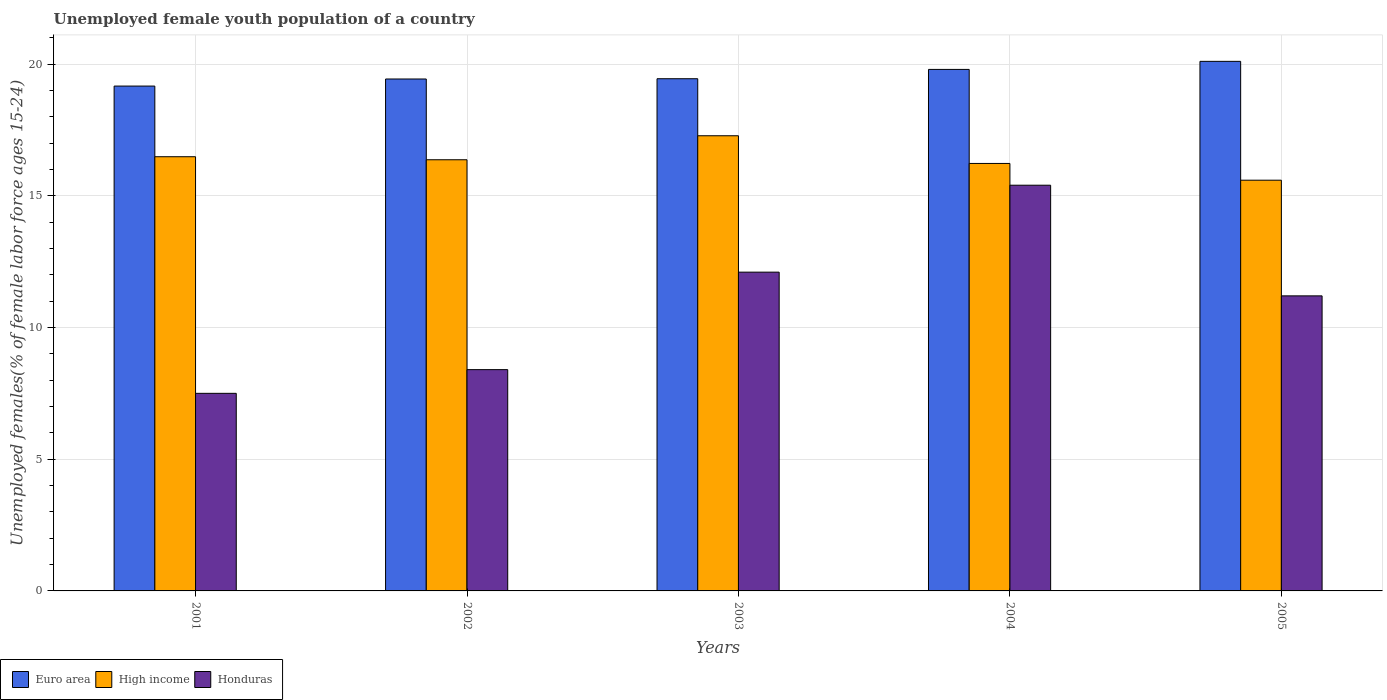Are the number of bars per tick equal to the number of legend labels?
Your answer should be very brief. Yes. How many bars are there on the 5th tick from the left?
Provide a succinct answer. 3. What is the label of the 5th group of bars from the left?
Keep it short and to the point. 2005. What is the percentage of unemployed female youth population in High income in 2002?
Offer a very short reply. 16.37. Across all years, what is the maximum percentage of unemployed female youth population in High income?
Keep it short and to the point. 17.28. Across all years, what is the minimum percentage of unemployed female youth population in Euro area?
Your response must be concise. 19.16. What is the total percentage of unemployed female youth population in High income in the graph?
Offer a terse response. 81.94. What is the difference between the percentage of unemployed female youth population in High income in 2003 and that in 2005?
Your answer should be compact. 1.69. What is the difference between the percentage of unemployed female youth population in High income in 2005 and the percentage of unemployed female youth population in Honduras in 2002?
Give a very brief answer. 7.19. What is the average percentage of unemployed female youth population in Euro area per year?
Your answer should be compact. 19.59. In the year 2001, what is the difference between the percentage of unemployed female youth population in Euro area and percentage of unemployed female youth population in High income?
Ensure brevity in your answer.  2.68. In how many years, is the percentage of unemployed female youth population in High income greater than 11 %?
Provide a short and direct response. 5. What is the ratio of the percentage of unemployed female youth population in High income in 2001 to that in 2002?
Your answer should be very brief. 1.01. Is the percentage of unemployed female youth population in Euro area in 2002 less than that in 2005?
Offer a terse response. Yes. Is the difference between the percentage of unemployed female youth population in Euro area in 2001 and 2004 greater than the difference between the percentage of unemployed female youth population in High income in 2001 and 2004?
Your answer should be compact. No. What is the difference between the highest and the second highest percentage of unemployed female youth population in Honduras?
Provide a succinct answer. 3.3. What is the difference between the highest and the lowest percentage of unemployed female youth population in Euro area?
Give a very brief answer. 0.94. How many years are there in the graph?
Your answer should be very brief. 5. Does the graph contain any zero values?
Ensure brevity in your answer.  No. Does the graph contain grids?
Your answer should be compact. Yes. How many legend labels are there?
Your answer should be compact. 3. What is the title of the graph?
Give a very brief answer. Unemployed female youth population of a country. Does "Kazakhstan" appear as one of the legend labels in the graph?
Offer a very short reply. No. What is the label or title of the X-axis?
Keep it short and to the point. Years. What is the label or title of the Y-axis?
Keep it short and to the point. Unemployed females(% of female labor force ages 15-24). What is the Unemployed females(% of female labor force ages 15-24) of Euro area in 2001?
Provide a short and direct response. 19.16. What is the Unemployed females(% of female labor force ages 15-24) of High income in 2001?
Ensure brevity in your answer.  16.48. What is the Unemployed females(% of female labor force ages 15-24) in Euro area in 2002?
Your answer should be compact. 19.43. What is the Unemployed females(% of female labor force ages 15-24) of High income in 2002?
Your answer should be very brief. 16.37. What is the Unemployed females(% of female labor force ages 15-24) in Honduras in 2002?
Keep it short and to the point. 8.4. What is the Unemployed females(% of female labor force ages 15-24) of Euro area in 2003?
Your answer should be compact. 19.44. What is the Unemployed females(% of female labor force ages 15-24) of High income in 2003?
Your response must be concise. 17.28. What is the Unemployed females(% of female labor force ages 15-24) of Honduras in 2003?
Give a very brief answer. 12.1. What is the Unemployed females(% of female labor force ages 15-24) of Euro area in 2004?
Your answer should be very brief. 19.8. What is the Unemployed females(% of female labor force ages 15-24) of High income in 2004?
Offer a very short reply. 16.23. What is the Unemployed females(% of female labor force ages 15-24) of Honduras in 2004?
Your response must be concise. 15.4. What is the Unemployed females(% of female labor force ages 15-24) in Euro area in 2005?
Make the answer very short. 20.1. What is the Unemployed females(% of female labor force ages 15-24) of High income in 2005?
Provide a succinct answer. 15.59. What is the Unemployed females(% of female labor force ages 15-24) of Honduras in 2005?
Offer a terse response. 11.2. Across all years, what is the maximum Unemployed females(% of female labor force ages 15-24) of Euro area?
Offer a very short reply. 20.1. Across all years, what is the maximum Unemployed females(% of female labor force ages 15-24) of High income?
Make the answer very short. 17.28. Across all years, what is the maximum Unemployed females(% of female labor force ages 15-24) of Honduras?
Ensure brevity in your answer.  15.4. Across all years, what is the minimum Unemployed females(% of female labor force ages 15-24) of Euro area?
Make the answer very short. 19.16. Across all years, what is the minimum Unemployed females(% of female labor force ages 15-24) in High income?
Keep it short and to the point. 15.59. Across all years, what is the minimum Unemployed females(% of female labor force ages 15-24) in Honduras?
Keep it short and to the point. 7.5. What is the total Unemployed females(% of female labor force ages 15-24) of Euro area in the graph?
Offer a terse response. 97.94. What is the total Unemployed females(% of female labor force ages 15-24) in High income in the graph?
Give a very brief answer. 81.94. What is the total Unemployed females(% of female labor force ages 15-24) of Honduras in the graph?
Ensure brevity in your answer.  54.6. What is the difference between the Unemployed females(% of female labor force ages 15-24) in Euro area in 2001 and that in 2002?
Your answer should be compact. -0.27. What is the difference between the Unemployed females(% of female labor force ages 15-24) of High income in 2001 and that in 2002?
Your response must be concise. 0.11. What is the difference between the Unemployed females(% of female labor force ages 15-24) in Euro area in 2001 and that in 2003?
Ensure brevity in your answer.  -0.28. What is the difference between the Unemployed females(% of female labor force ages 15-24) of High income in 2001 and that in 2003?
Give a very brief answer. -0.8. What is the difference between the Unemployed females(% of female labor force ages 15-24) in Euro area in 2001 and that in 2004?
Your answer should be very brief. -0.63. What is the difference between the Unemployed females(% of female labor force ages 15-24) of High income in 2001 and that in 2004?
Your response must be concise. 0.25. What is the difference between the Unemployed females(% of female labor force ages 15-24) of Honduras in 2001 and that in 2004?
Your answer should be very brief. -7.9. What is the difference between the Unemployed females(% of female labor force ages 15-24) of Euro area in 2001 and that in 2005?
Provide a succinct answer. -0.94. What is the difference between the Unemployed females(% of female labor force ages 15-24) in High income in 2001 and that in 2005?
Give a very brief answer. 0.89. What is the difference between the Unemployed females(% of female labor force ages 15-24) of Euro area in 2002 and that in 2003?
Give a very brief answer. -0.01. What is the difference between the Unemployed females(% of female labor force ages 15-24) of High income in 2002 and that in 2003?
Provide a succinct answer. -0.91. What is the difference between the Unemployed females(% of female labor force ages 15-24) in Euro area in 2002 and that in 2004?
Provide a succinct answer. -0.36. What is the difference between the Unemployed females(% of female labor force ages 15-24) of High income in 2002 and that in 2004?
Your answer should be compact. 0.14. What is the difference between the Unemployed females(% of female labor force ages 15-24) in Euro area in 2002 and that in 2005?
Provide a short and direct response. -0.67. What is the difference between the Unemployed females(% of female labor force ages 15-24) of High income in 2002 and that in 2005?
Ensure brevity in your answer.  0.78. What is the difference between the Unemployed females(% of female labor force ages 15-24) of Euro area in 2003 and that in 2004?
Keep it short and to the point. -0.35. What is the difference between the Unemployed females(% of female labor force ages 15-24) in High income in 2003 and that in 2004?
Keep it short and to the point. 1.05. What is the difference between the Unemployed females(% of female labor force ages 15-24) of Honduras in 2003 and that in 2004?
Keep it short and to the point. -3.3. What is the difference between the Unemployed females(% of female labor force ages 15-24) of Euro area in 2003 and that in 2005?
Your response must be concise. -0.66. What is the difference between the Unemployed females(% of female labor force ages 15-24) of High income in 2003 and that in 2005?
Your answer should be very brief. 1.69. What is the difference between the Unemployed females(% of female labor force ages 15-24) in Euro area in 2004 and that in 2005?
Your answer should be compact. -0.31. What is the difference between the Unemployed females(% of female labor force ages 15-24) in High income in 2004 and that in 2005?
Keep it short and to the point. 0.64. What is the difference between the Unemployed females(% of female labor force ages 15-24) in Honduras in 2004 and that in 2005?
Keep it short and to the point. 4.2. What is the difference between the Unemployed females(% of female labor force ages 15-24) in Euro area in 2001 and the Unemployed females(% of female labor force ages 15-24) in High income in 2002?
Your answer should be very brief. 2.8. What is the difference between the Unemployed females(% of female labor force ages 15-24) of Euro area in 2001 and the Unemployed females(% of female labor force ages 15-24) of Honduras in 2002?
Give a very brief answer. 10.76. What is the difference between the Unemployed females(% of female labor force ages 15-24) in High income in 2001 and the Unemployed females(% of female labor force ages 15-24) in Honduras in 2002?
Ensure brevity in your answer.  8.08. What is the difference between the Unemployed females(% of female labor force ages 15-24) of Euro area in 2001 and the Unemployed females(% of female labor force ages 15-24) of High income in 2003?
Your answer should be very brief. 1.89. What is the difference between the Unemployed females(% of female labor force ages 15-24) of Euro area in 2001 and the Unemployed females(% of female labor force ages 15-24) of Honduras in 2003?
Keep it short and to the point. 7.06. What is the difference between the Unemployed females(% of female labor force ages 15-24) in High income in 2001 and the Unemployed females(% of female labor force ages 15-24) in Honduras in 2003?
Make the answer very short. 4.38. What is the difference between the Unemployed females(% of female labor force ages 15-24) in Euro area in 2001 and the Unemployed females(% of female labor force ages 15-24) in High income in 2004?
Provide a succinct answer. 2.94. What is the difference between the Unemployed females(% of female labor force ages 15-24) in Euro area in 2001 and the Unemployed females(% of female labor force ages 15-24) in Honduras in 2004?
Your response must be concise. 3.76. What is the difference between the Unemployed females(% of female labor force ages 15-24) in High income in 2001 and the Unemployed females(% of female labor force ages 15-24) in Honduras in 2004?
Provide a succinct answer. 1.08. What is the difference between the Unemployed females(% of female labor force ages 15-24) in Euro area in 2001 and the Unemployed females(% of female labor force ages 15-24) in High income in 2005?
Give a very brief answer. 3.57. What is the difference between the Unemployed females(% of female labor force ages 15-24) in Euro area in 2001 and the Unemployed females(% of female labor force ages 15-24) in Honduras in 2005?
Your answer should be compact. 7.96. What is the difference between the Unemployed females(% of female labor force ages 15-24) in High income in 2001 and the Unemployed females(% of female labor force ages 15-24) in Honduras in 2005?
Your answer should be very brief. 5.28. What is the difference between the Unemployed females(% of female labor force ages 15-24) of Euro area in 2002 and the Unemployed females(% of female labor force ages 15-24) of High income in 2003?
Keep it short and to the point. 2.15. What is the difference between the Unemployed females(% of female labor force ages 15-24) in Euro area in 2002 and the Unemployed females(% of female labor force ages 15-24) in Honduras in 2003?
Keep it short and to the point. 7.33. What is the difference between the Unemployed females(% of female labor force ages 15-24) of High income in 2002 and the Unemployed females(% of female labor force ages 15-24) of Honduras in 2003?
Keep it short and to the point. 4.27. What is the difference between the Unemployed females(% of female labor force ages 15-24) in Euro area in 2002 and the Unemployed females(% of female labor force ages 15-24) in High income in 2004?
Your answer should be compact. 3.21. What is the difference between the Unemployed females(% of female labor force ages 15-24) of Euro area in 2002 and the Unemployed females(% of female labor force ages 15-24) of Honduras in 2004?
Offer a terse response. 4.03. What is the difference between the Unemployed females(% of female labor force ages 15-24) of High income in 2002 and the Unemployed females(% of female labor force ages 15-24) of Honduras in 2004?
Your answer should be compact. 0.97. What is the difference between the Unemployed females(% of female labor force ages 15-24) in Euro area in 2002 and the Unemployed females(% of female labor force ages 15-24) in High income in 2005?
Offer a very short reply. 3.84. What is the difference between the Unemployed females(% of female labor force ages 15-24) of Euro area in 2002 and the Unemployed females(% of female labor force ages 15-24) of Honduras in 2005?
Your answer should be very brief. 8.23. What is the difference between the Unemployed females(% of female labor force ages 15-24) in High income in 2002 and the Unemployed females(% of female labor force ages 15-24) in Honduras in 2005?
Your answer should be compact. 5.17. What is the difference between the Unemployed females(% of female labor force ages 15-24) of Euro area in 2003 and the Unemployed females(% of female labor force ages 15-24) of High income in 2004?
Keep it short and to the point. 3.22. What is the difference between the Unemployed females(% of female labor force ages 15-24) of Euro area in 2003 and the Unemployed females(% of female labor force ages 15-24) of Honduras in 2004?
Your answer should be very brief. 4.04. What is the difference between the Unemployed females(% of female labor force ages 15-24) in High income in 2003 and the Unemployed females(% of female labor force ages 15-24) in Honduras in 2004?
Provide a short and direct response. 1.88. What is the difference between the Unemployed females(% of female labor force ages 15-24) of Euro area in 2003 and the Unemployed females(% of female labor force ages 15-24) of High income in 2005?
Your answer should be very brief. 3.85. What is the difference between the Unemployed females(% of female labor force ages 15-24) of Euro area in 2003 and the Unemployed females(% of female labor force ages 15-24) of Honduras in 2005?
Ensure brevity in your answer.  8.24. What is the difference between the Unemployed females(% of female labor force ages 15-24) of High income in 2003 and the Unemployed females(% of female labor force ages 15-24) of Honduras in 2005?
Offer a very short reply. 6.08. What is the difference between the Unemployed females(% of female labor force ages 15-24) in Euro area in 2004 and the Unemployed females(% of female labor force ages 15-24) in High income in 2005?
Provide a short and direct response. 4.21. What is the difference between the Unemployed females(% of female labor force ages 15-24) in Euro area in 2004 and the Unemployed females(% of female labor force ages 15-24) in Honduras in 2005?
Provide a succinct answer. 8.6. What is the difference between the Unemployed females(% of female labor force ages 15-24) in High income in 2004 and the Unemployed females(% of female labor force ages 15-24) in Honduras in 2005?
Your response must be concise. 5.03. What is the average Unemployed females(% of female labor force ages 15-24) of Euro area per year?
Keep it short and to the point. 19.59. What is the average Unemployed females(% of female labor force ages 15-24) in High income per year?
Your answer should be compact. 16.39. What is the average Unemployed females(% of female labor force ages 15-24) of Honduras per year?
Offer a terse response. 10.92. In the year 2001, what is the difference between the Unemployed females(% of female labor force ages 15-24) of Euro area and Unemployed females(% of female labor force ages 15-24) of High income?
Your answer should be compact. 2.68. In the year 2001, what is the difference between the Unemployed females(% of female labor force ages 15-24) of Euro area and Unemployed females(% of female labor force ages 15-24) of Honduras?
Provide a succinct answer. 11.66. In the year 2001, what is the difference between the Unemployed females(% of female labor force ages 15-24) of High income and Unemployed females(% of female labor force ages 15-24) of Honduras?
Your response must be concise. 8.98. In the year 2002, what is the difference between the Unemployed females(% of female labor force ages 15-24) of Euro area and Unemployed females(% of female labor force ages 15-24) of High income?
Offer a very short reply. 3.07. In the year 2002, what is the difference between the Unemployed females(% of female labor force ages 15-24) of Euro area and Unemployed females(% of female labor force ages 15-24) of Honduras?
Your answer should be very brief. 11.03. In the year 2002, what is the difference between the Unemployed females(% of female labor force ages 15-24) in High income and Unemployed females(% of female labor force ages 15-24) in Honduras?
Offer a terse response. 7.97. In the year 2003, what is the difference between the Unemployed females(% of female labor force ages 15-24) in Euro area and Unemployed females(% of female labor force ages 15-24) in High income?
Offer a terse response. 2.16. In the year 2003, what is the difference between the Unemployed females(% of female labor force ages 15-24) of Euro area and Unemployed females(% of female labor force ages 15-24) of Honduras?
Provide a short and direct response. 7.34. In the year 2003, what is the difference between the Unemployed females(% of female labor force ages 15-24) in High income and Unemployed females(% of female labor force ages 15-24) in Honduras?
Make the answer very short. 5.18. In the year 2004, what is the difference between the Unemployed females(% of female labor force ages 15-24) of Euro area and Unemployed females(% of female labor force ages 15-24) of High income?
Give a very brief answer. 3.57. In the year 2004, what is the difference between the Unemployed females(% of female labor force ages 15-24) of Euro area and Unemployed females(% of female labor force ages 15-24) of Honduras?
Your response must be concise. 4.4. In the year 2004, what is the difference between the Unemployed females(% of female labor force ages 15-24) in High income and Unemployed females(% of female labor force ages 15-24) in Honduras?
Ensure brevity in your answer.  0.83. In the year 2005, what is the difference between the Unemployed females(% of female labor force ages 15-24) of Euro area and Unemployed females(% of female labor force ages 15-24) of High income?
Keep it short and to the point. 4.51. In the year 2005, what is the difference between the Unemployed females(% of female labor force ages 15-24) of Euro area and Unemployed females(% of female labor force ages 15-24) of Honduras?
Your answer should be compact. 8.9. In the year 2005, what is the difference between the Unemployed females(% of female labor force ages 15-24) of High income and Unemployed females(% of female labor force ages 15-24) of Honduras?
Keep it short and to the point. 4.39. What is the ratio of the Unemployed females(% of female labor force ages 15-24) in Euro area in 2001 to that in 2002?
Offer a terse response. 0.99. What is the ratio of the Unemployed females(% of female labor force ages 15-24) of Honduras in 2001 to that in 2002?
Your answer should be compact. 0.89. What is the ratio of the Unemployed females(% of female labor force ages 15-24) of Euro area in 2001 to that in 2003?
Provide a short and direct response. 0.99. What is the ratio of the Unemployed females(% of female labor force ages 15-24) of High income in 2001 to that in 2003?
Your answer should be very brief. 0.95. What is the ratio of the Unemployed females(% of female labor force ages 15-24) of Honduras in 2001 to that in 2003?
Keep it short and to the point. 0.62. What is the ratio of the Unemployed females(% of female labor force ages 15-24) in Euro area in 2001 to that in 2004?
Your answer should be compact. 0.97. What is the ratio of the Unemployed females(% of female labor force ages 15-24) in High income in 2001 to that in 2004?
Provide a short and direct response. 1.02. What is the ratio of the Unemployed females(% of female labor force ages 15-24) in Honduras in 2001 to that in 2004?
Your answer should be very brief. 0.49. What is the ratio of the Unemployed females(% of female labor force ages 15-24) of Euro area in 2001 to that in 2005?
Make the answer very short. 0.95. What is the ratio of the Unemployed females(% of female labor force ages 15-24) in High income in 2001 to that in 2005?
Provide a short and direct response. 1.06. What is the ratio of the Unemployed females(% of female labor force ages 15-24) of Honduras in 2001 to that in 2005?
Provide a short and direct response. 0.67. What is the ratio of the Unemployed females(% of female labor force ages 15-24) in High income in 2002 to that in 2003?
Give a very brief answer. 0.95. What is the ratio of the Unemployed females(% of female labor force ages 15-24) of Honduras in 2002 to that in 2003?
Your answer should be compact. 0.69. What is the ratio of the Unemployed females(% of female labor force ages 15-24) in Euro area in 2002 to that in 2004?
Provide a short and direct response. 0.98. What is the ratio of the Unemployed females(% of female labor force ages 15-24) of High income in 2002 to that in 2004?
Your answer should be compact. 1.01. What is the ratio of the Unemployed females(% of female labor force ages 15-24) in Honduras in 2002 to that in 2004?
Your answer should be very brief. 0.55. What is the ratio of the Unemployed females(% of female labor force ages 15-24) in Euro area in 2002 to that in 2005?
Your answer should be very brief. 0.97. What is the ratio of the Unemployed females(% of female labor force ages 15-24) of High income in 2002 to that in 2005?
Offer a very short reply. 1.05. What is the ratio of the Unemployed females(% of female labor force ages 15-24) of Euro area in 2003 to that in 2004?
Make the answer very short. 0.98. What is the ratio of the Unemployed females(% of female labor force ages 15-24) of High income in 2003 to that in 2004?
Your answer should be very brief. 1.06. What is the ratio of the Unemployed females(% of female labor force ages 15-24) of Honduras in 2003 to that in 2004?
Provide a succinct answer. 0.79. What is the ratio of the Unemployed females(% of female labor force ages 15-24) of Euro area in 2003 to that in 2005?
Provide a short and direct response. 0.97. What is the ratio of the Unemployed females(% of female labor force ages 15-24) in High income in 2003 to that in 2005?
Your answer should be very brief. 1.11. What is the ratio of the Unemployed females(% of female labor force ages 15-24) of Honduras in 2003 to that in 2005?
Offer a terse response. 1.08. What is the ratio of the Unemployed females(% of female labor force ages 15-24) of Euro area in 2004 to that in 2005?
Provide a short and direct response. 0.98. What is the ratio of the Unemployed females(% of female labor force ages 15-24) of High income in 2004 to that in 2005?
Your response must be concise. 1.04. What is the ratio of the Unemployed females(% of female labor force ages 15-24) of Honduras in 2004 to that in 2005?
Offer a very short reply. 1.38. What is the difference between the highest and the second highest Unemployed females(% of female labor force ages 15-24) of Euro area?
Keep it short and to the point. 0.31. What is the difference between the highest and the second highest Unemployed females(% of female labor force ages 15-24) in High income?
Provide a short and direct response. 0.8. What is the difference between the highest and the lowest Unemployed females(% of female labor force ages 15-24) in Euro area?
Your answer should be very brief. 0.94. What is the difference between the highest and the lowest Unemployed females(% of female labor force ages 15-24) in High income?
Make the answer very short. 1.69. What is the difference between the highest and the lowest Unemployed females(% of female labor force ages 15-24) in Honduras?
Provide a succinct answer. 7.9. 